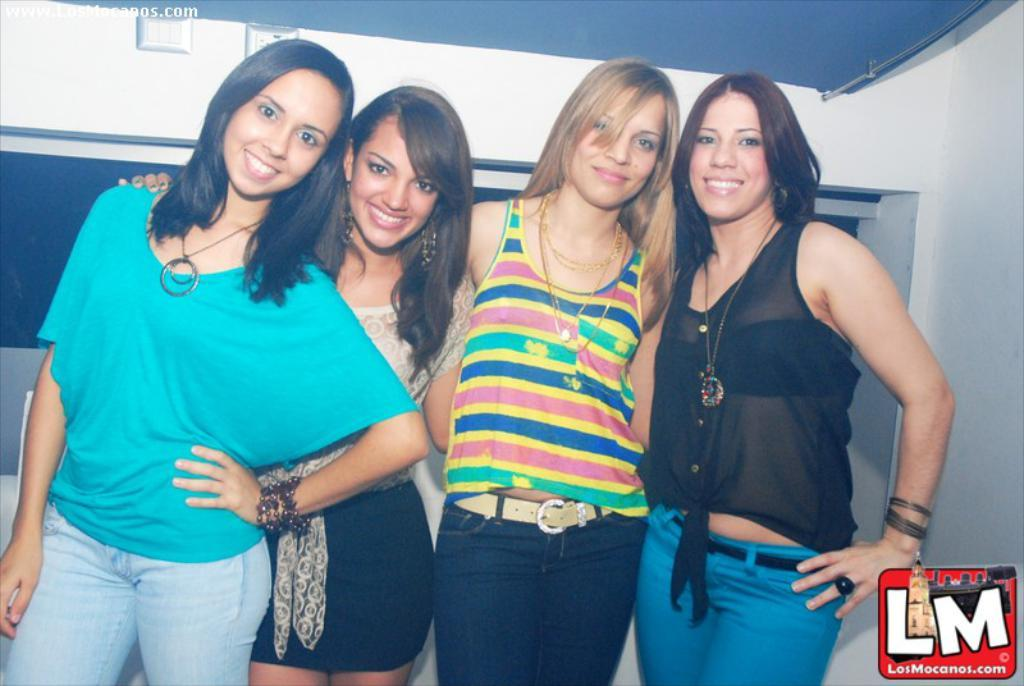How many people are present in the image? There are four women standing in the image. What can be seen in the background of the image? There is a wall in the background of the image. Where is the logo located in the image? The logo is at the right bottom of the image. Can you tell me which aunt is wearing a watch on her wrist in the image? There is no mention of an aunt or a watch in the image; it features four women standing with a wall in the background and a logo at the right bottom. 